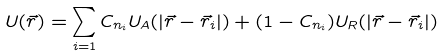Convert formula to latex. <formula><loc_0><loc_0><loc_500><loc_500>U ( \vec { r } ) = \sum _ { i = 1 } C _ { n _ { i } } U _ { A } ( | \vec { r } - \vec { r } _ { i } | ) + ( 1 - C _ { n _ { i } } ) U _ { R } ( | \vec { r } - \vec { r } _ { i } | )</formula> 